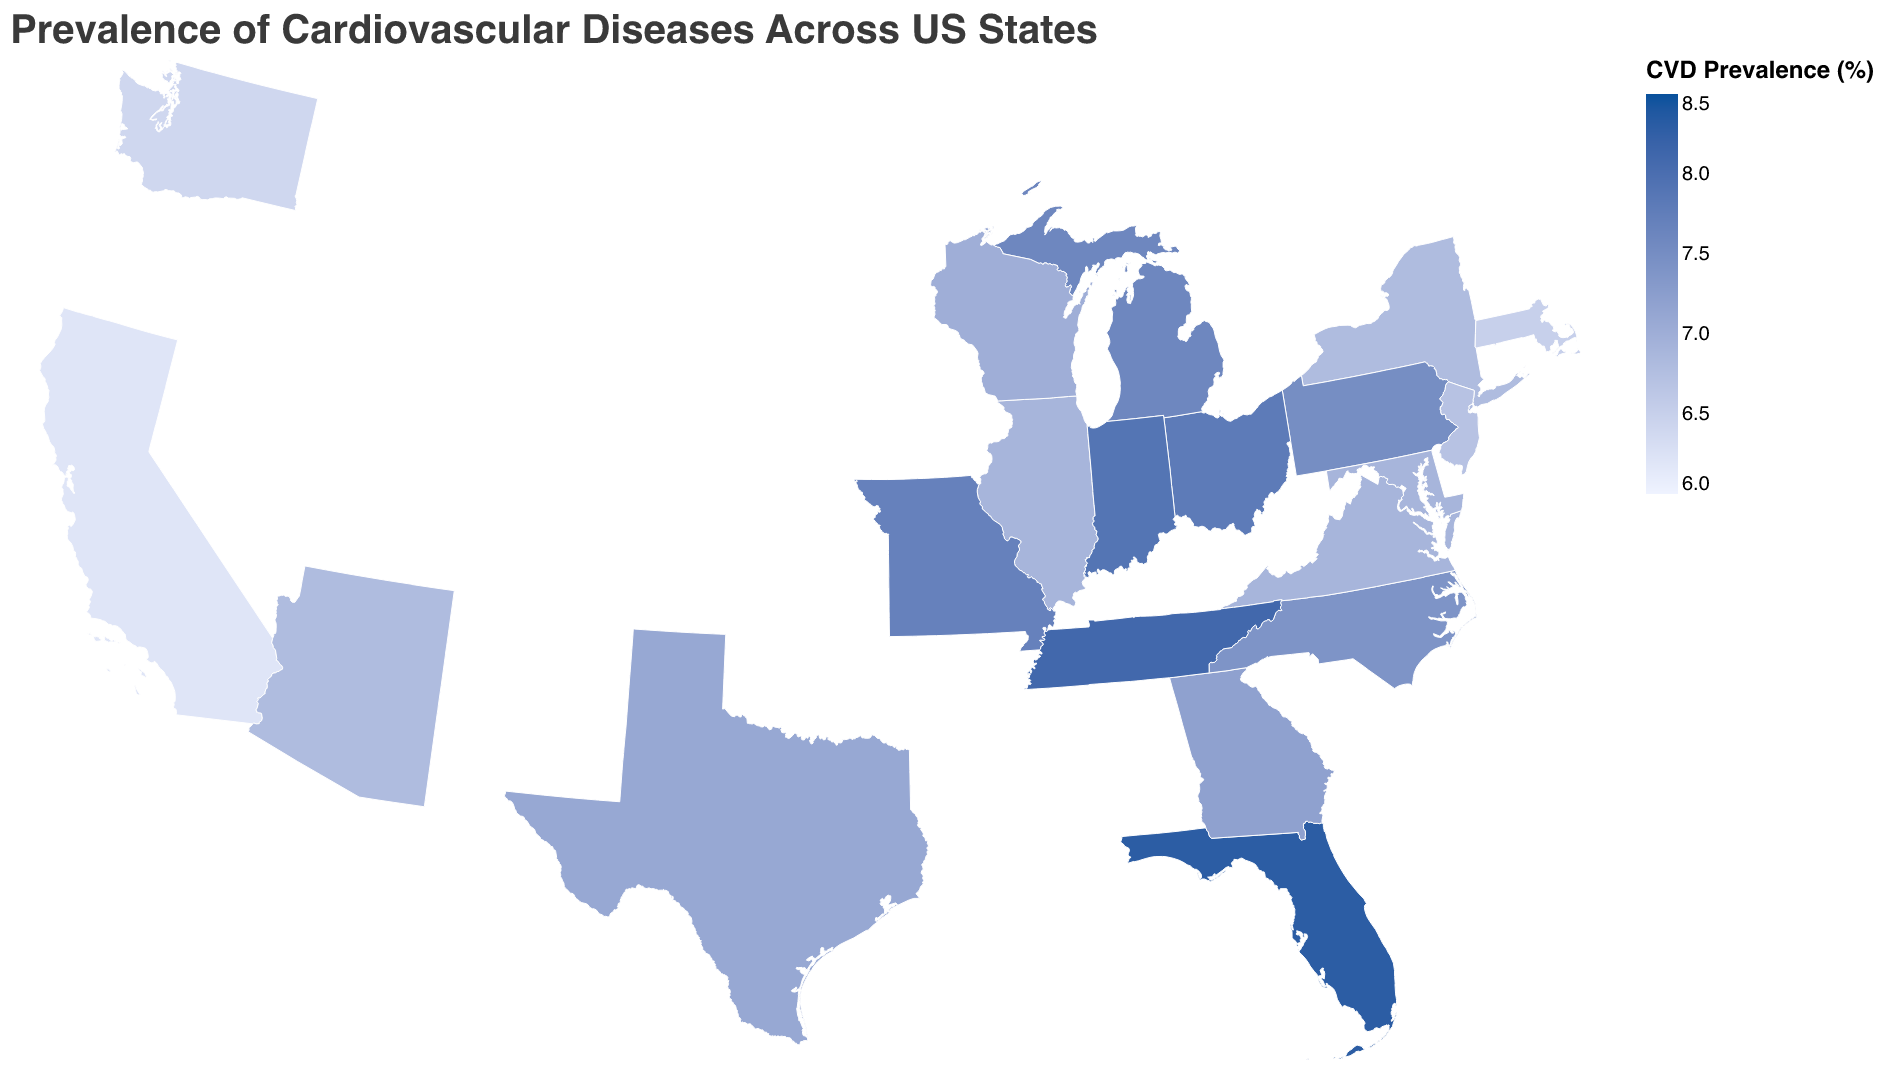What's the title of the figure? The title of the figure is typically located at the top of the plot and provides an overall description of what the figure represents. The title here reads "Prevalence of Cardiovascular Diseases Across US States".
Answer: Prevalence of Cardiovascular Diseases Across US States Which state has the highest prevalence of cardiovascular diseases? To determine the state with the highest prevalence, look for the state with the darkest color on the plot since a darker color indicates a higher prevalence. According to the data, Florida has the highest prevalence at 8.3%.
Answer: Florida What is the prevalence rate of cardiovascular diseases in California? The plot provides tooltip information for each state, and California's tooltip would show the prevalence rate of 6.2%.
Answer: 6.2% How many states have a cardiovascular disease prevalence rate above 7%? Visually inspect the choropleth map and identify states with a darker shade. According to the data, the states with a prevalence rate above 7% are Texas, Florida, Pennsylvania, Ohio, Georgia, North Carolina, Michigan, Tennessee, Indiana, and Missouri. Counting these states gives us a total of 10.
Answer: 10 What's the difference in cardiovascular disease prevalence between New York and New Jersey? The prevalence for New York is 6.8% and for New Jersey is 6.7%. The difference is calculated as 6.8% - 6.7% = 0.1%.
Answer: 0.1% Which state has the lowest prevalence of cardiovascular diseases? To find the state with the lowest prevalence, look for the lightest color on the plot. According to the data, California and Washington (both at 6.2%) have the lowest prevalence rates.
Answer: California and Washington Compare the cardiovascular disease prevalence between Texas and Arizona. Which state has a higher rate? According to the data, Texas has a prevalence rate of 7.1% while Arizona has a prevalence rate of 6.8%. Thus, Texas has a higher rate.
Answer: Texas What is the average prevalence rate of cardiovascular diseases for all the states listed in the data? Add up all the prevalence rates and divide by the number of states: (6.2 + 7.1 + 8.3 + 6.8 + 6.9 + 7.5 + 7.8 + 7.2 + 7.4 + 7.6 + 6.7 + 6.9 + 6.4 + 6.5 + 6.8 + 8.1 + 7.9 + 7.7 + 6.9 + 7.0)/20 = 7.12.
Answer: 7.12% Which is the darker shade, signifying higher prevalence: Pennsylvania or Virginia? Compare the colors of both states on the choropleth map. The data reveals Pennsylvania has a prevalence of 7.5% while Virginia has 6.9%, so Pennsylvania should appear darker.
Answer: Pennsylvania What is the median prevalence rate of cardiovascular diseases for the states listed? To find the median, first list the rates in ascending order: 6.2, 6.2, 6.4, 6.5, 6.7, 6.8, 6.8, 6.8, 6.9, 6.9, 6.9, 7.0, 7.1, 7.2, 7.4, 7.5, 7.6, 7.7, 7.8, 7.9, 8.1, 8.3. The middle values are 6.9 and 6.9, so the median is (6.9 + 6.9)/2 = 6.9.
Answer: 6.9 